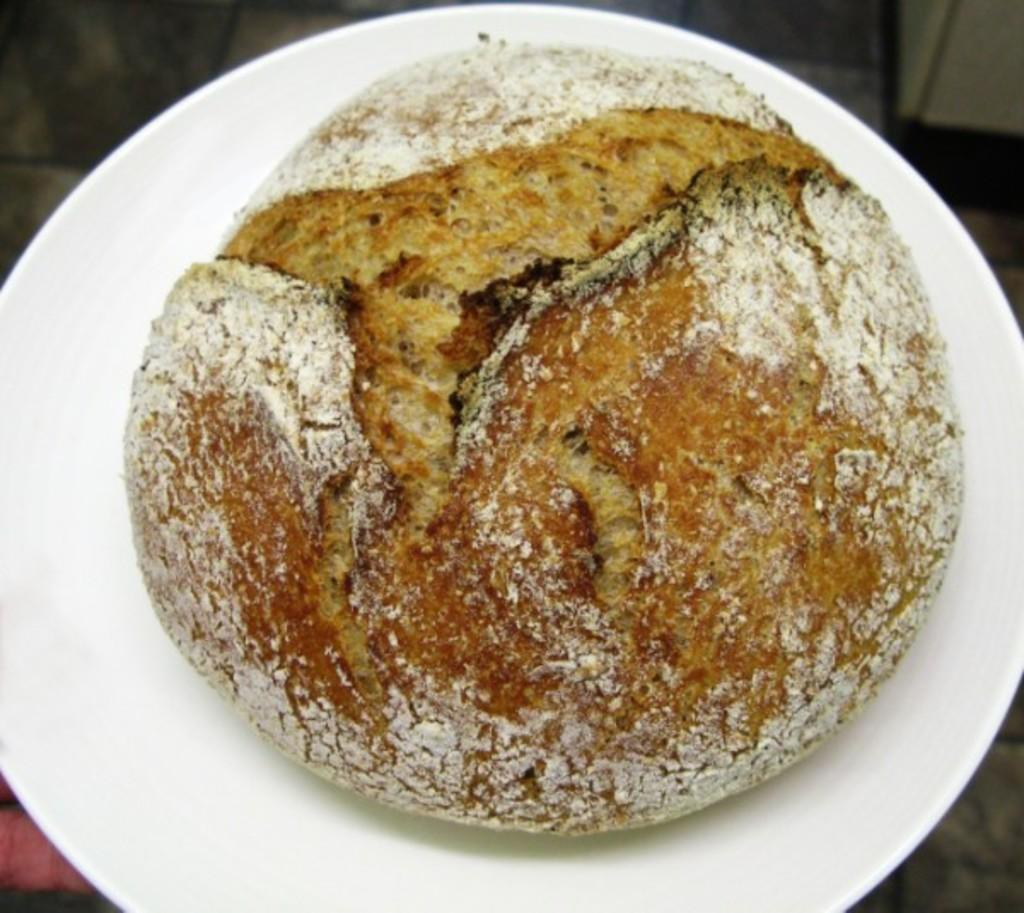What is located in the center of the image? There is a plate in the center of the image. What is on the plate? There is a food item on the plate. Can you describe the background of the image? The background of the image is blurred. What type of song can be heard in the background of the image? There is no sound or song present in the image, as it is a still photograph. 